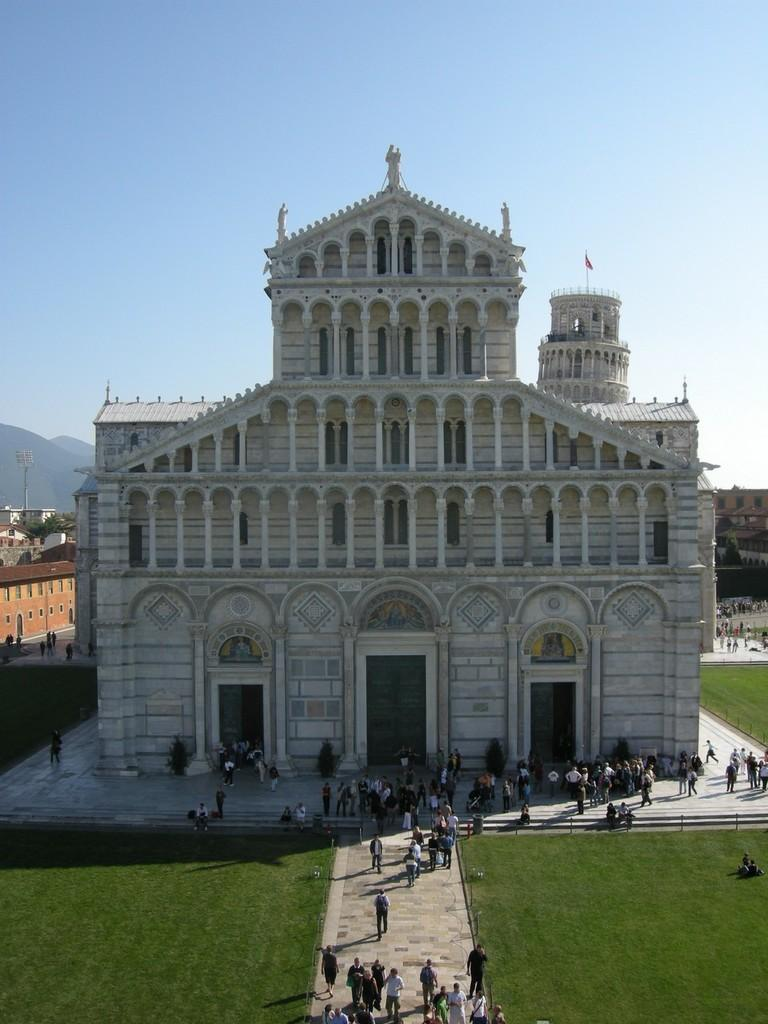What can be seen in the foreground of the image? There are persons in the front of the image. What type of ground is visible in the image? There is grass on the ground. What structures are visible in the background of the image? There are buildings in the background of the image. What type of natural feature can be seen in the background of the image? There are mountains visible in the background of the image. What is visible at the top of the image? The sky is visible at the top of the image. Are the persons in the image wearing masks? There is no information about masks in the image; it only shows persons, grass, buildings, mountains, and the sky. What type of peace can be seen in the image? There is no reference to peace in the image; it is a scene with persons, grass, buildings, mountains, and the sky. 